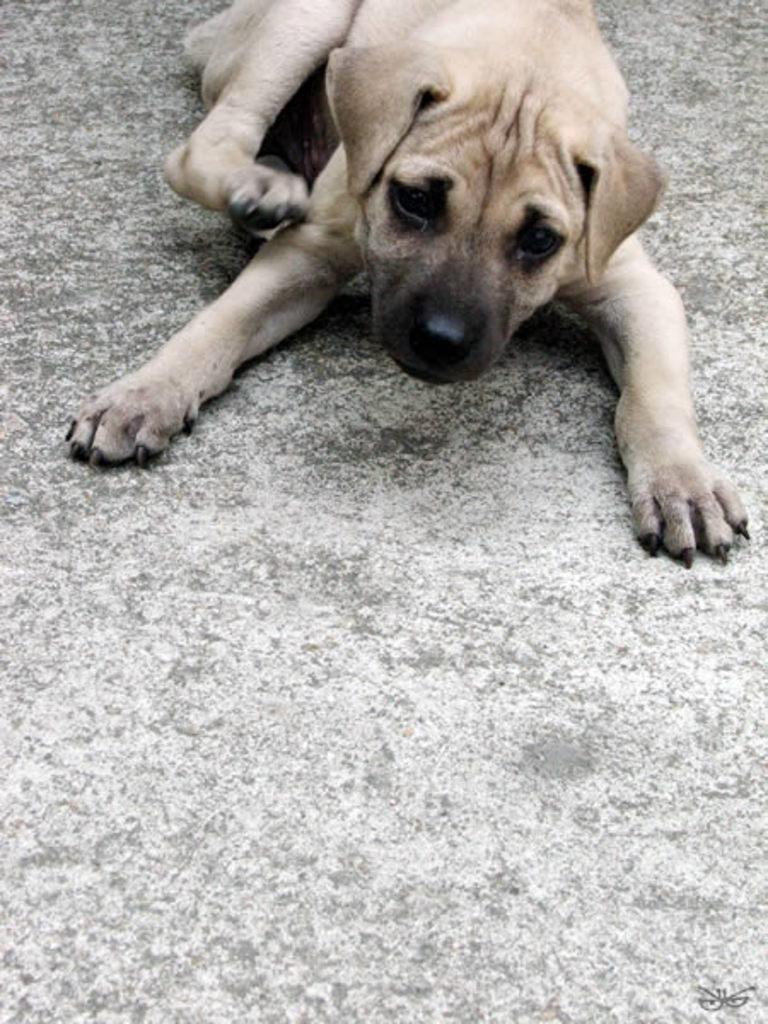Please provide a concise description of this image. In this image we can see a dog on the surface. 